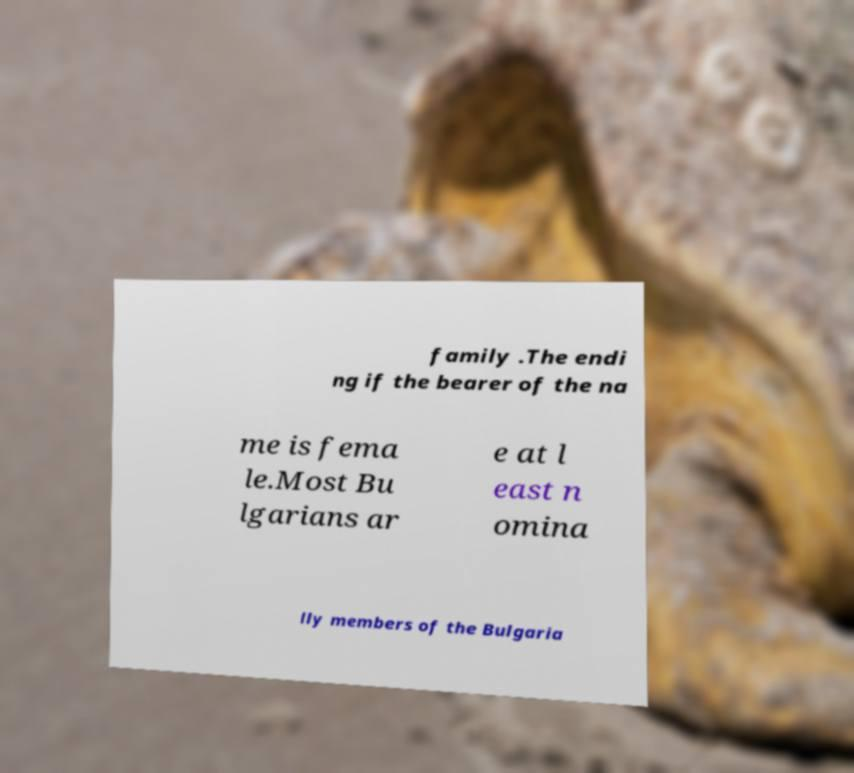Please read and relay the text visible in this image. What does it say? family .The endi ng if the bearer of the na me is fema le.Most Bu lgarians ar e at l east n omina lly members of the Bulgaria 